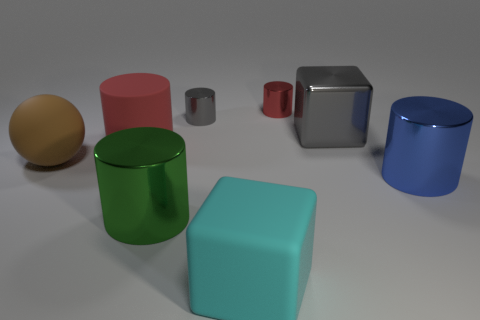Subtract all tiny red metallic cylinders. How many cylinders are left? 4 Subtract all yellow spheres. How many red cylinders are left? 2 Subtract all gray cylinders. How many cylinders are left? 4 Add 1 gray shiny cylinders. How many objects exist? 9 Subtract all spheres. How many objects are left? 7 Subtract all purple cylinders. Subtract all purple balls. How many cylinders are left? 5 Subtract all small gray shiny things. Subtract all large red rubber objects. How many objects are left? 6 Add 2 big green metal cylinders. How many big green metal cylinders are left? 3 Add 7 green blocks. How many green blocks exist? 7 Subtract 0 purple cubes. How many objects are left? 8 